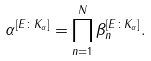<formula> <loc_0><loc_0><loc_500><loc_500>\alpha ^ { [ E \colon K _ { \alpha } ] } = \prod _ { n = 1 } ^ { N } \beta _ { n } ^ { [ E \colon K _ { \alpha } ] } .</formula> 